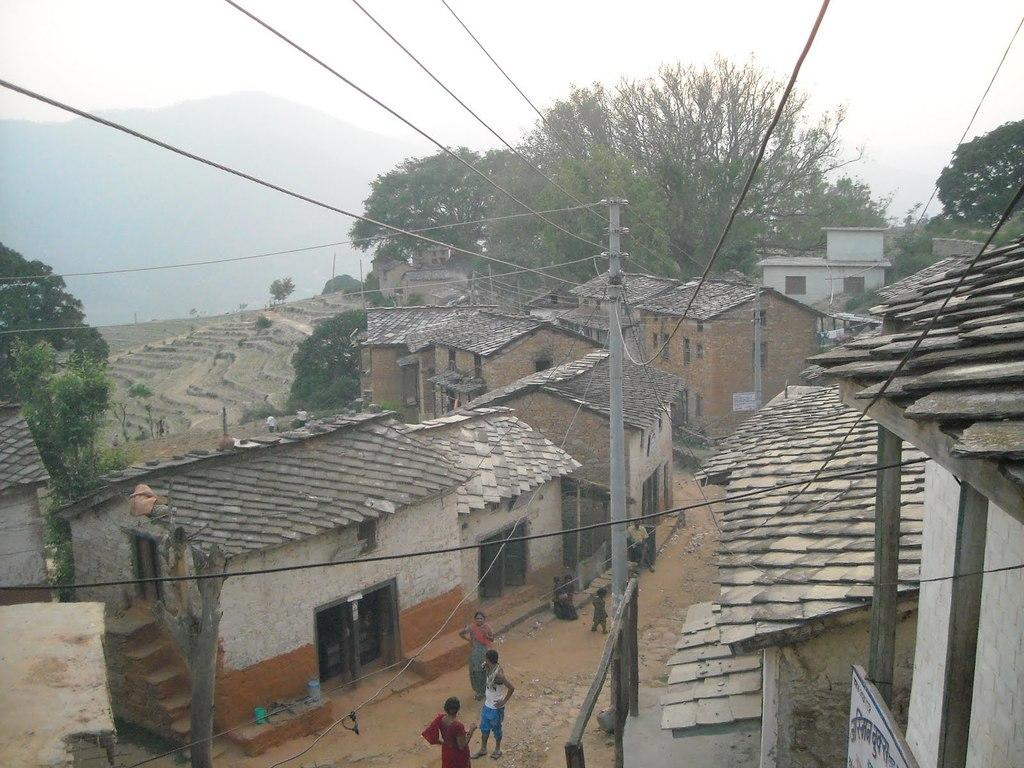What can be seen on the road in the image? There are people on the road in the image. What is the purpose of the name board in the image? The name board in the image is likely used for identification or direction. What are the poles and wires in the image used for? The poles and wires in the image are likely used for electrical or communication purposes. What type of vegetation is present in the image? There are trees in the image. What type of structures can be seen in the image? There are buildings in the image. What geographical feature is visible in the image? There are mountains in the image. What other objects can be seen in the image? There are some objects in the image. What is visible in the background of the image? The sky is visible in the background of the image. Can you see any shade provided by the trees in the image? There is no mention of shade in the provided facts, so we cannot determine if the trees provide shade in the image. Are there any cobwebs visible on the poles or buildings in the image? There is no mention of cobwebs in the provided facts, so we cannot determine if any are visible in the image. 